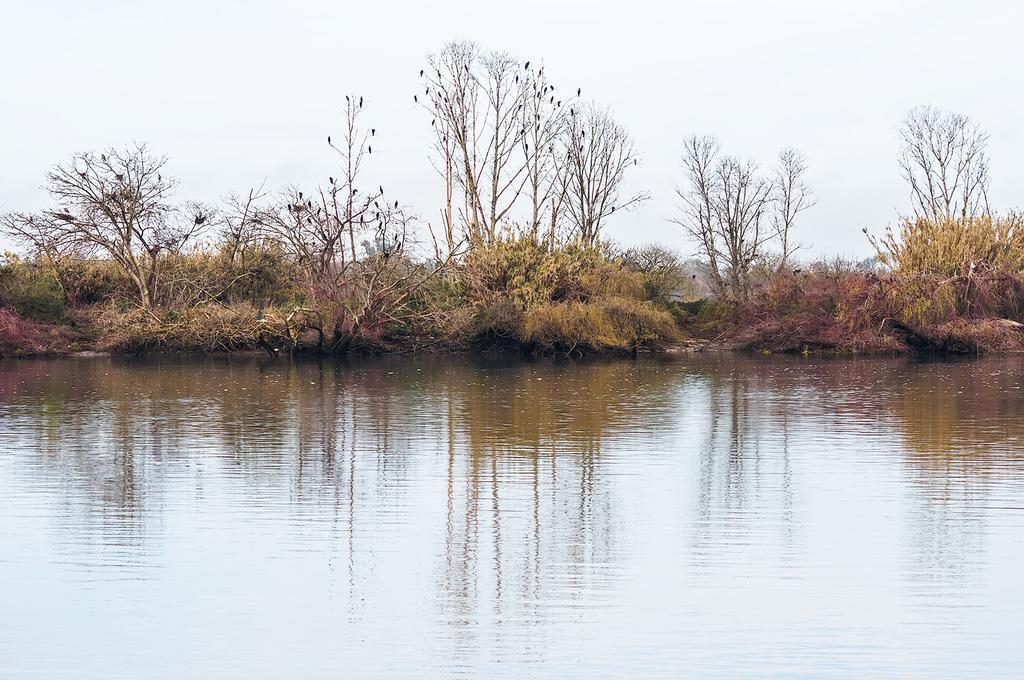Can you describe this image briefly? In the picture I can see water and there are plants and trees in the background. 